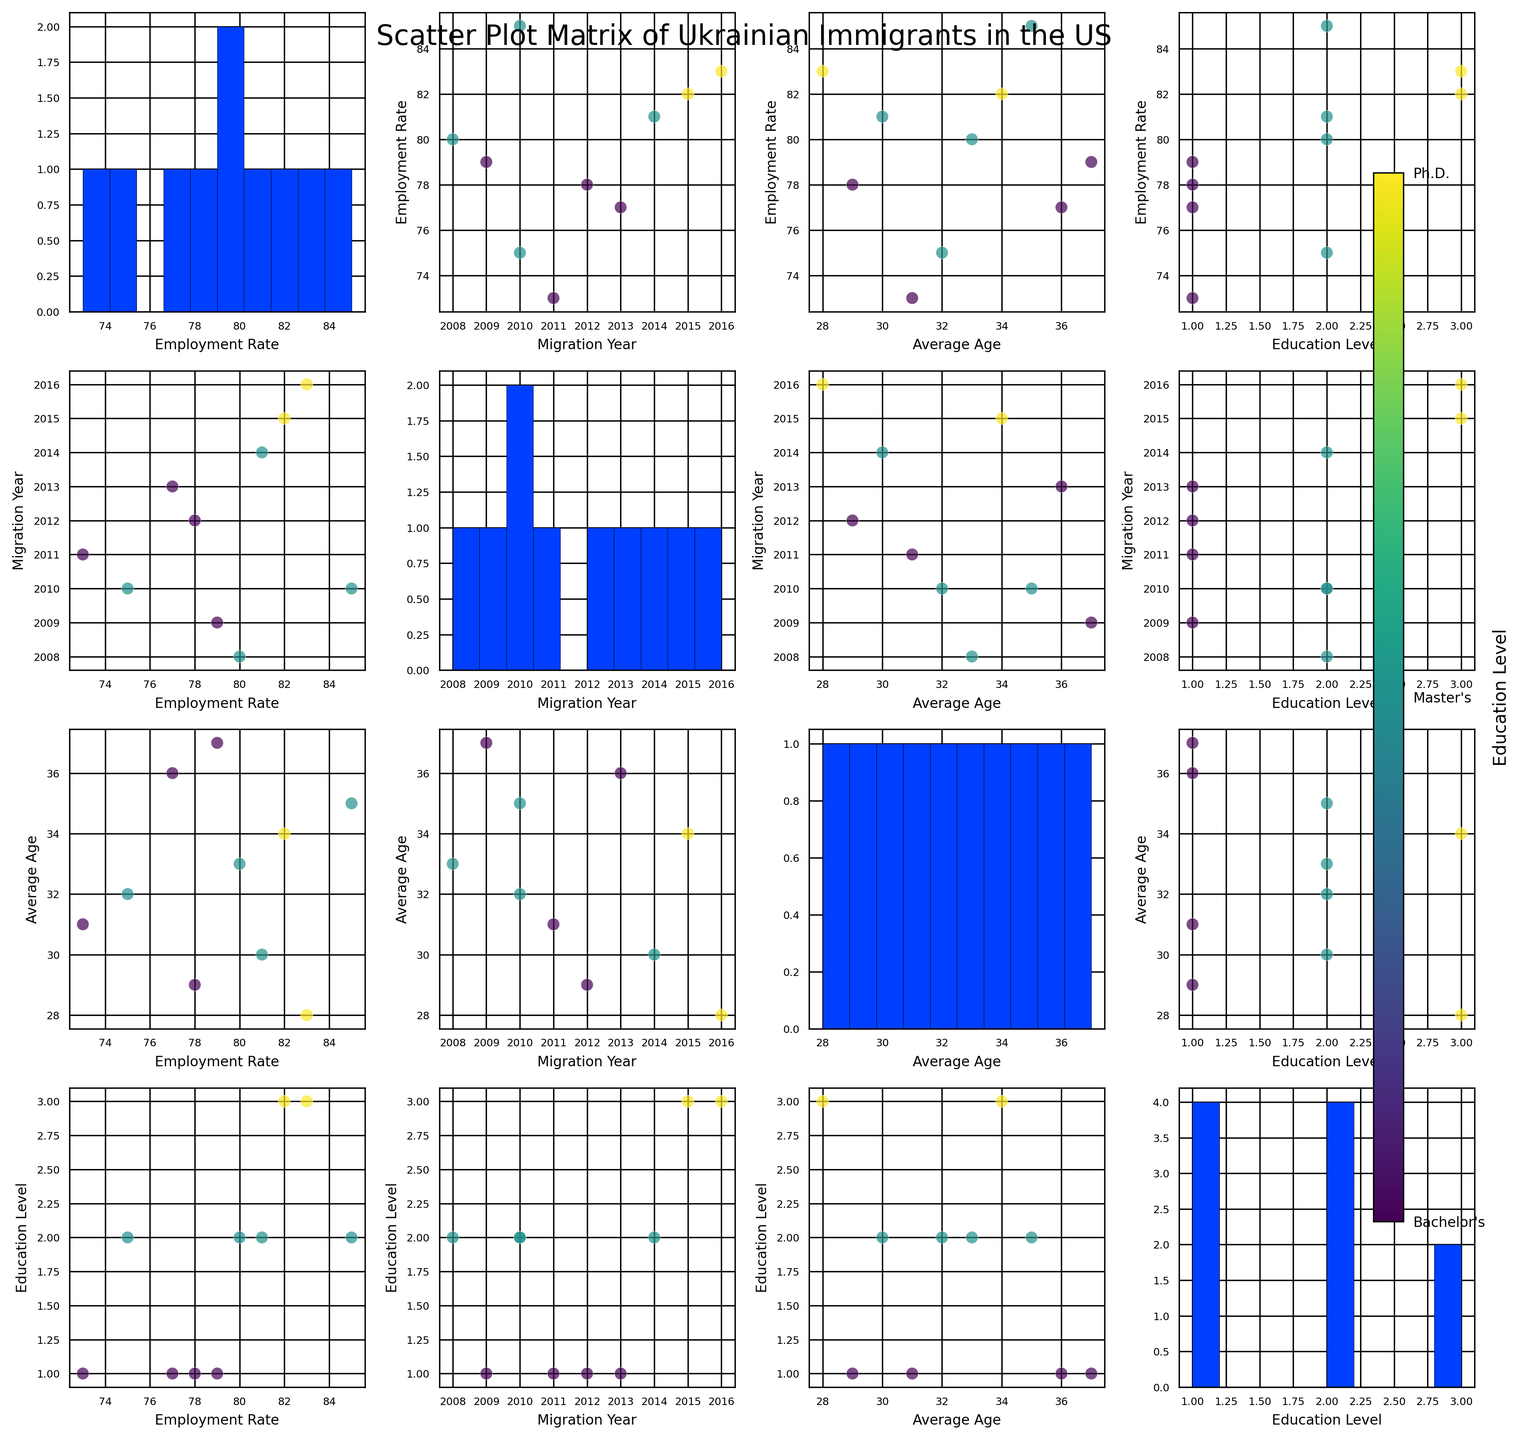What's the average employment rate of the cities listed? To find the average employment rate, sum the employment rates of all cities and divide by the number of cities. The sum is (85 + 78 + 82 + 73 + 80 + 77 + 75 + 83 + 79 + 81) = 793. There are 10 cities, so the average employment rate is 793/10 = 79.3
Answer: 79.3 Which city has the highest education level? By looking at the color gradient in the scatter plots, the darkest color represents the highest education level (Ph.D.), corresponding to Kharkiv and Vinnytsia.
Answer: Kharkiv and Vinnytsia Is there any noticeable trend between the employment rate and education level? In the scatter plot of employment rate vs. education level, we can check for any visible patterns. Higher education levels (Master's and Ph.D.) generally cluster at the higher end of employment rates, suggesting a positive correlation.
Answer: Positive correlation Which city has the oldest average age? In the histogram for average age, the city with the highest bar value in the "36-37" bin corresponds to Chernihiv, with an average age of 37.
Answer: Chernihiv What is the relationship between migration year and average age? By examining the scatter plot of migration year vs. average age, if dots form a specific pattern (like increasing or decreasing with respect to the axes), a relationship can be inferred. The pattern suggests that people who migrated earlier (e.g., 2008, 2009) belong to older age categories.
Answer: Earlier migrants are older Do people with a Master's degree tend to have higher employment rates than those with a Bachelor's degree? From the scatter plots, identify and compare the clustering of points colored differently. On average, points corresponding to a Master's degree appear higher on the employment rate axis compared to those with a Bachelor's degree.
Answer: Yes Which city has the lowest employment rate and what is its education level? By checking the scatter plot of employment rate vs. cities, the lowest value corresponds to Odesa with an employment rate of 73 and a Bachelor's degree (indicated by color).
Answer: Odesa, Bachelor's degree How does the distribution of employment rate look like? By observing the histogram corresponding to the employment rate, there are a few peaks and the spread ranges from approximately 73 to 85.
Answer: Peaks and spread from 73 to 85 Is there any trend between the average age and employment rate? Examine the scatter plot of average age vs. employment rate to identify any apparent trends. There doesn’t seem to be a clear linear trend, indicating a weak or no correlation between average age and employment rate.
Answer: No clear trend Which migration year had the youngest average age? By checking the scatter plot for average age vs. migration year, identify the lowest point for average age. Vinnytsia, with the youngest average age of 28 in the migration year 2016.
Answer: 2016 